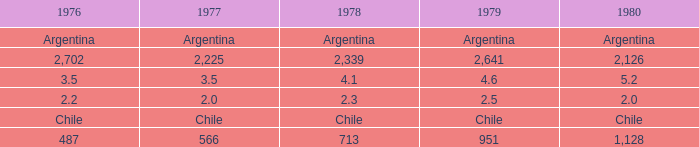What is 1980 when 1978 is 2.3? 2.0. 